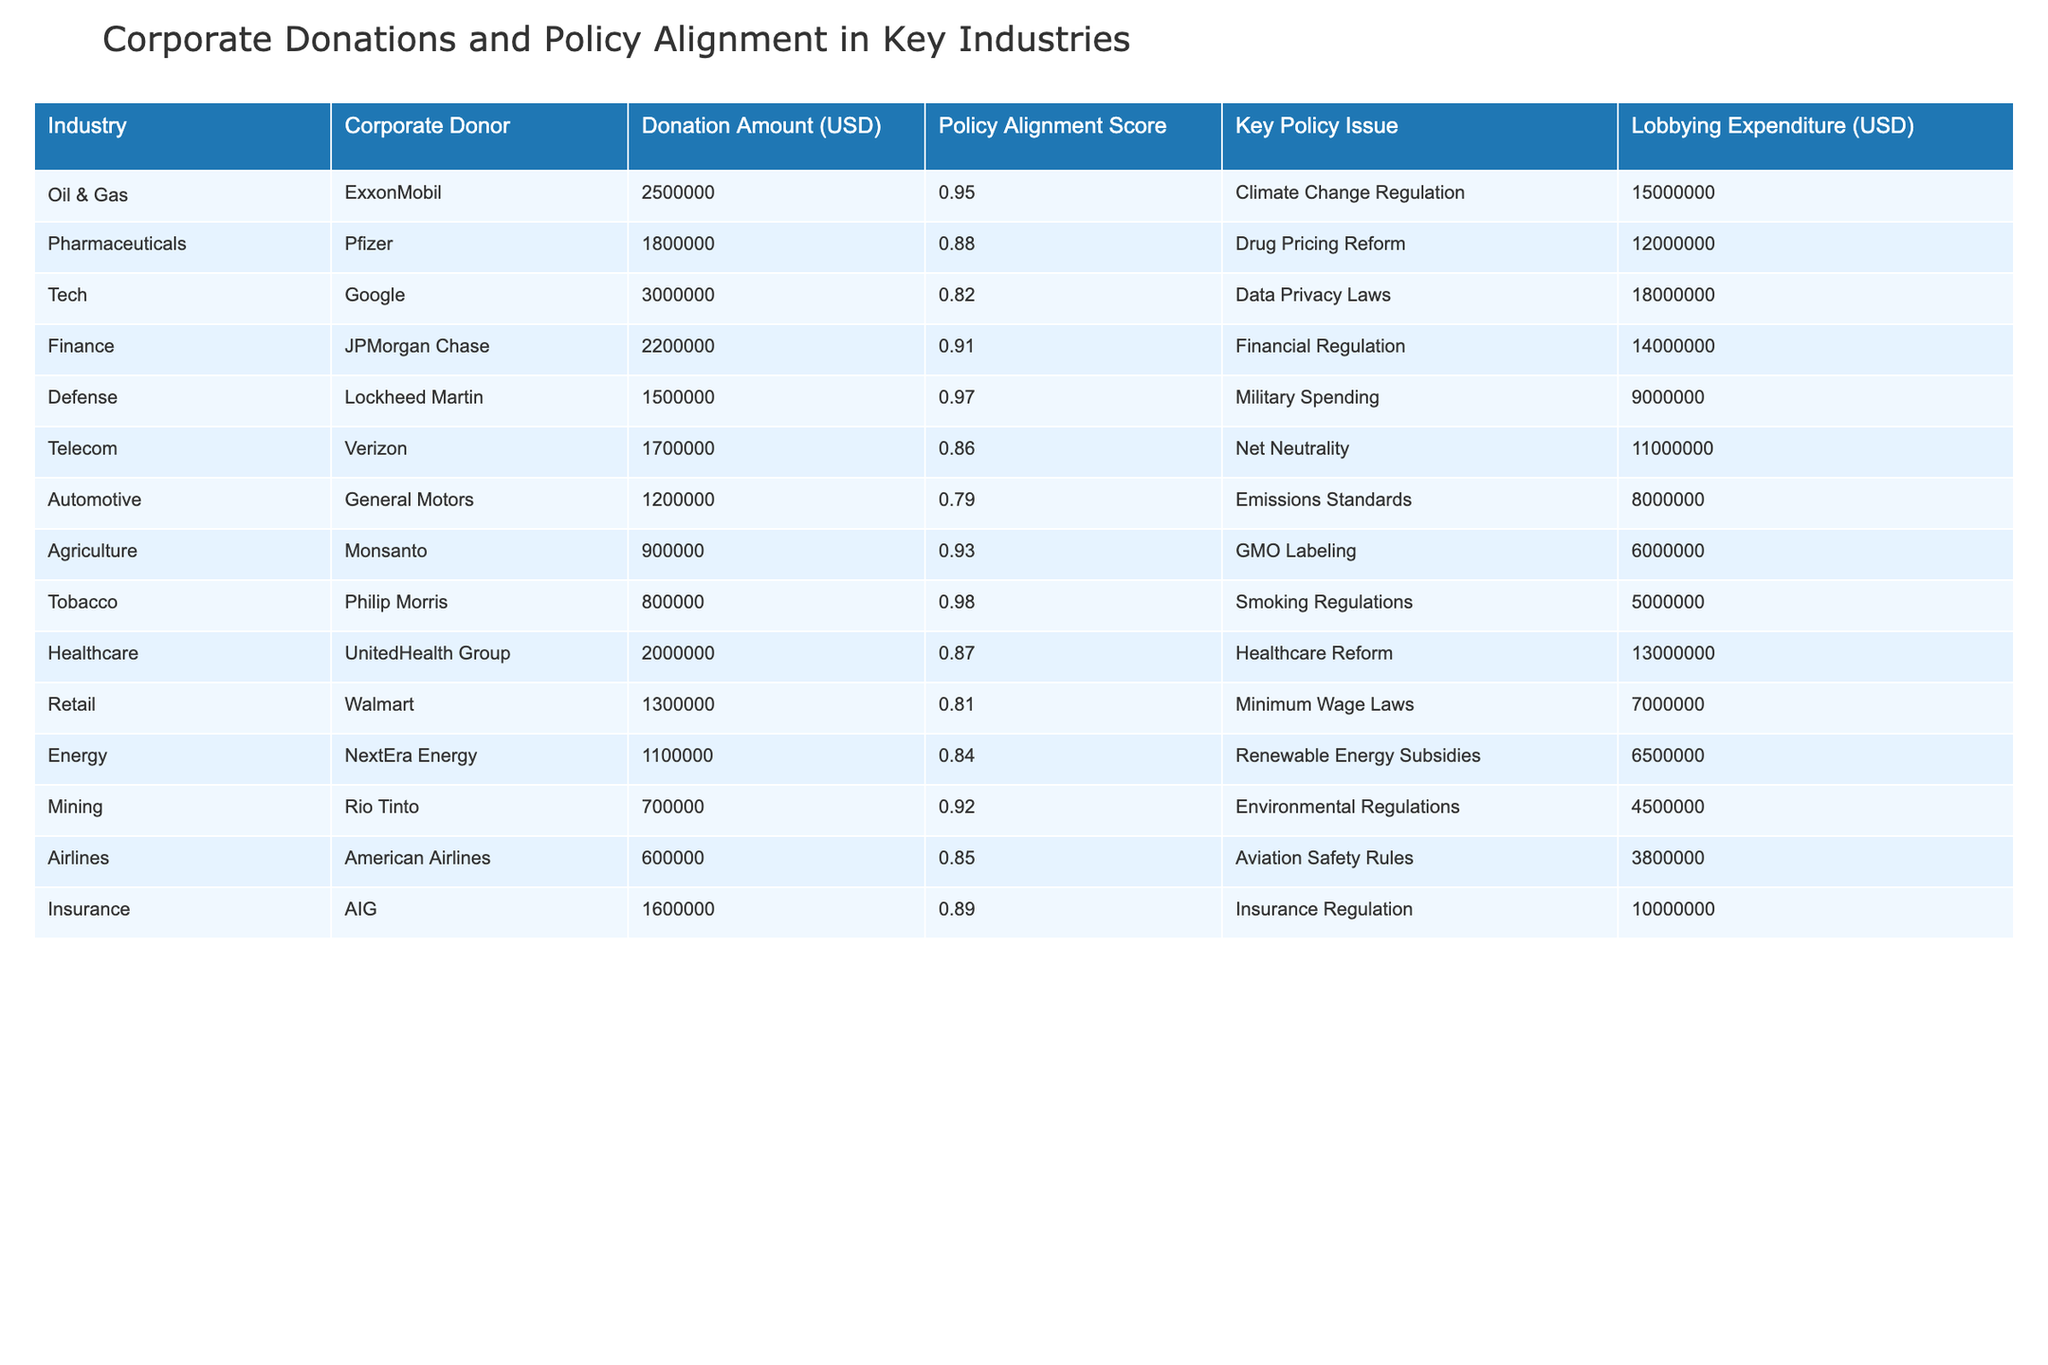What is the total amount donated by the Tobacco industry? The table shows that Philip Morris is the corporate donor from the Tobacco industry, with a donation amount of 800,000 USD. Thus, the total amount donated by the Tobacco industry is simply the donation from Philip Morris, which is 800,000 USD.
Answer: 800000 Which industry has the highest Policy Alignment Score? Upon reviewing the Policy Alignment Scores, Lockheed Martin from the Defense industry has the highest score at 0.97. Therefore, the Defense industry stands out with the highest Policy Alignment Score in the table.
Answer: Defense What is the average Donation Amount for the top three industries by donation amount? The top three industries by donation amount are Tech (3,000,000 USD), Oil & Gas (2,500,000 USD), and Finance (2,200,000 USD). The sum of these donations is 3,000,000 + 2,500,000 + 2,200,000 = 7,700,000 USD. Dividing this by 3 (the number of industries) gives an average of 7,700,000 / 3 = 2,566,667 USD.
Answer: 2566667 Is there a direct correlation between high donation amounts and high Policy Alignment Scores? To investigate this, we analyze the data by checking industries with the highest donations and their corresponding Policy Alignment Scores. For instance, Google has the highest donation amount but a lower Policy Alignment Score of 0.82, and ExxonMobil has a high amount but a score of 0.95. This indicates that while there is some correlation, it is not strictly linear as the industry with the highest donation does not have the highest score. Therefore, we conclude there is no definitive correlation.
Answer: No Which industry has the least lobbying expenditure? Reviewing the 'Lobbying Expenditure' column, we find that American Airlines in the Airlines industry has the least lobbying expenditure at 600,000 USD. This makes the Airlines industry the one with the least expenditure on lobbying as reflected in the table.
Answer: Airlines 